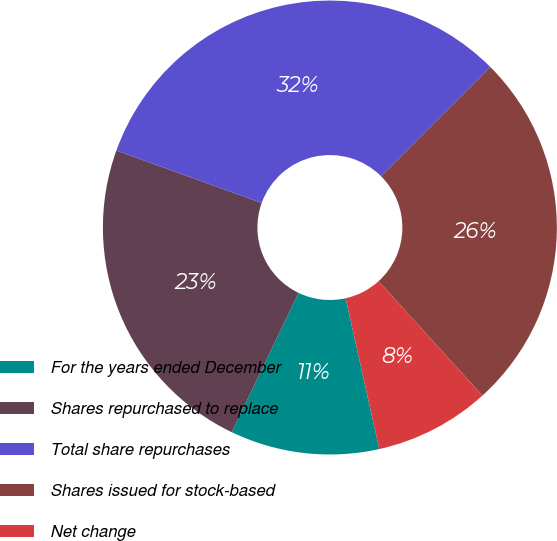<chart> <loc_0><loc_0><loc_500><loc_500><pie_chart><fcel>For the years ended December<fcel>Shares repurchased to replace<fcel>Total share repurchases<fcel>Shares issued for stock-based<fcel>Net change<nl><fcel>10.61%<fcel>23.39%<fcel>31.99%<fcel>25.77%<fcel>8.24%<nl></chart> 